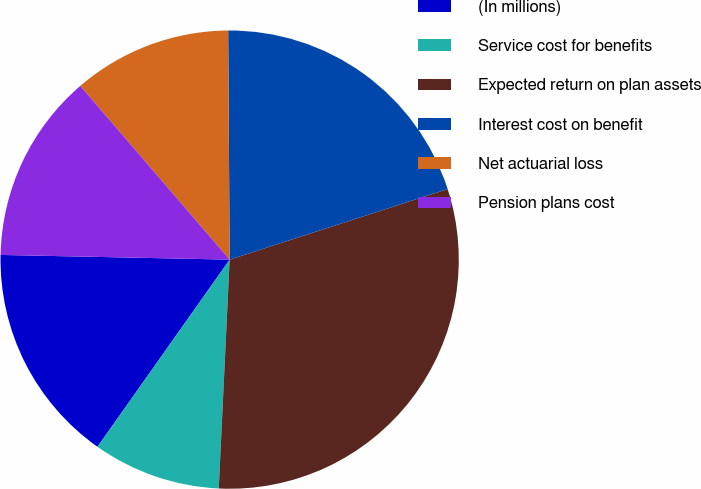<chart> <loc_0><loc_0><loc_500><loc_500><pie_chart><fcel>(In millions)<fcel>Service cost for benefits<fcel>Expected return on plan assets<fcel>Interest cost on benefit<fcel>Net actuarial loss<fcel>Pension plans cost<nl><fcel>15.54%<fcel>9.03%<fcel>30.74%<fcel>20.12%<fcel>11.2%<fcel>13.37%<nl></chart> 